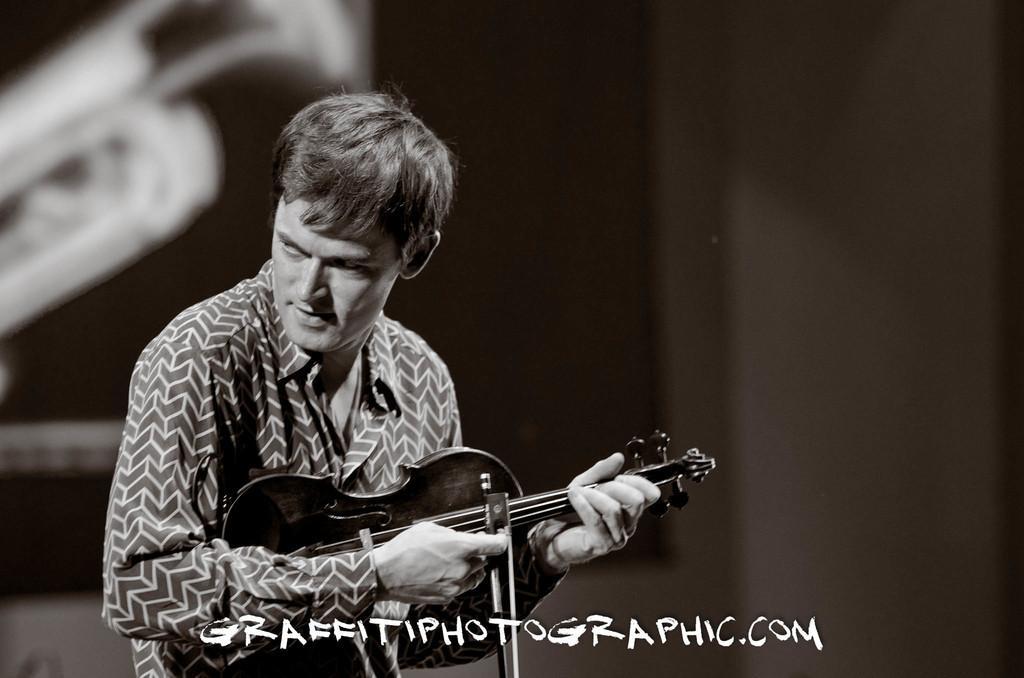Please provide a concise description of this image. The person is standing and playing guitar in his hand. 